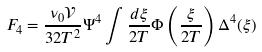Convert formula to latex. <formula><loc_0><loc_0><loc_500><loc_500>F _ { 4 } = \frac { \nu _ { 0 } \mathcal { V } } { 3 2 T ^ { 2 } } \Psi ^ { 4 } \int \frac { d \xi } { 2 T } \Phi \left ( \frac { \xi } { 2 T } \right ) \Delta ^ { 4 } ( \xi )</formula> 